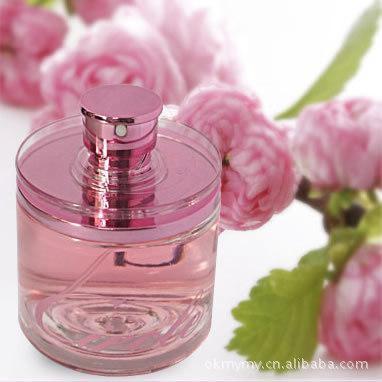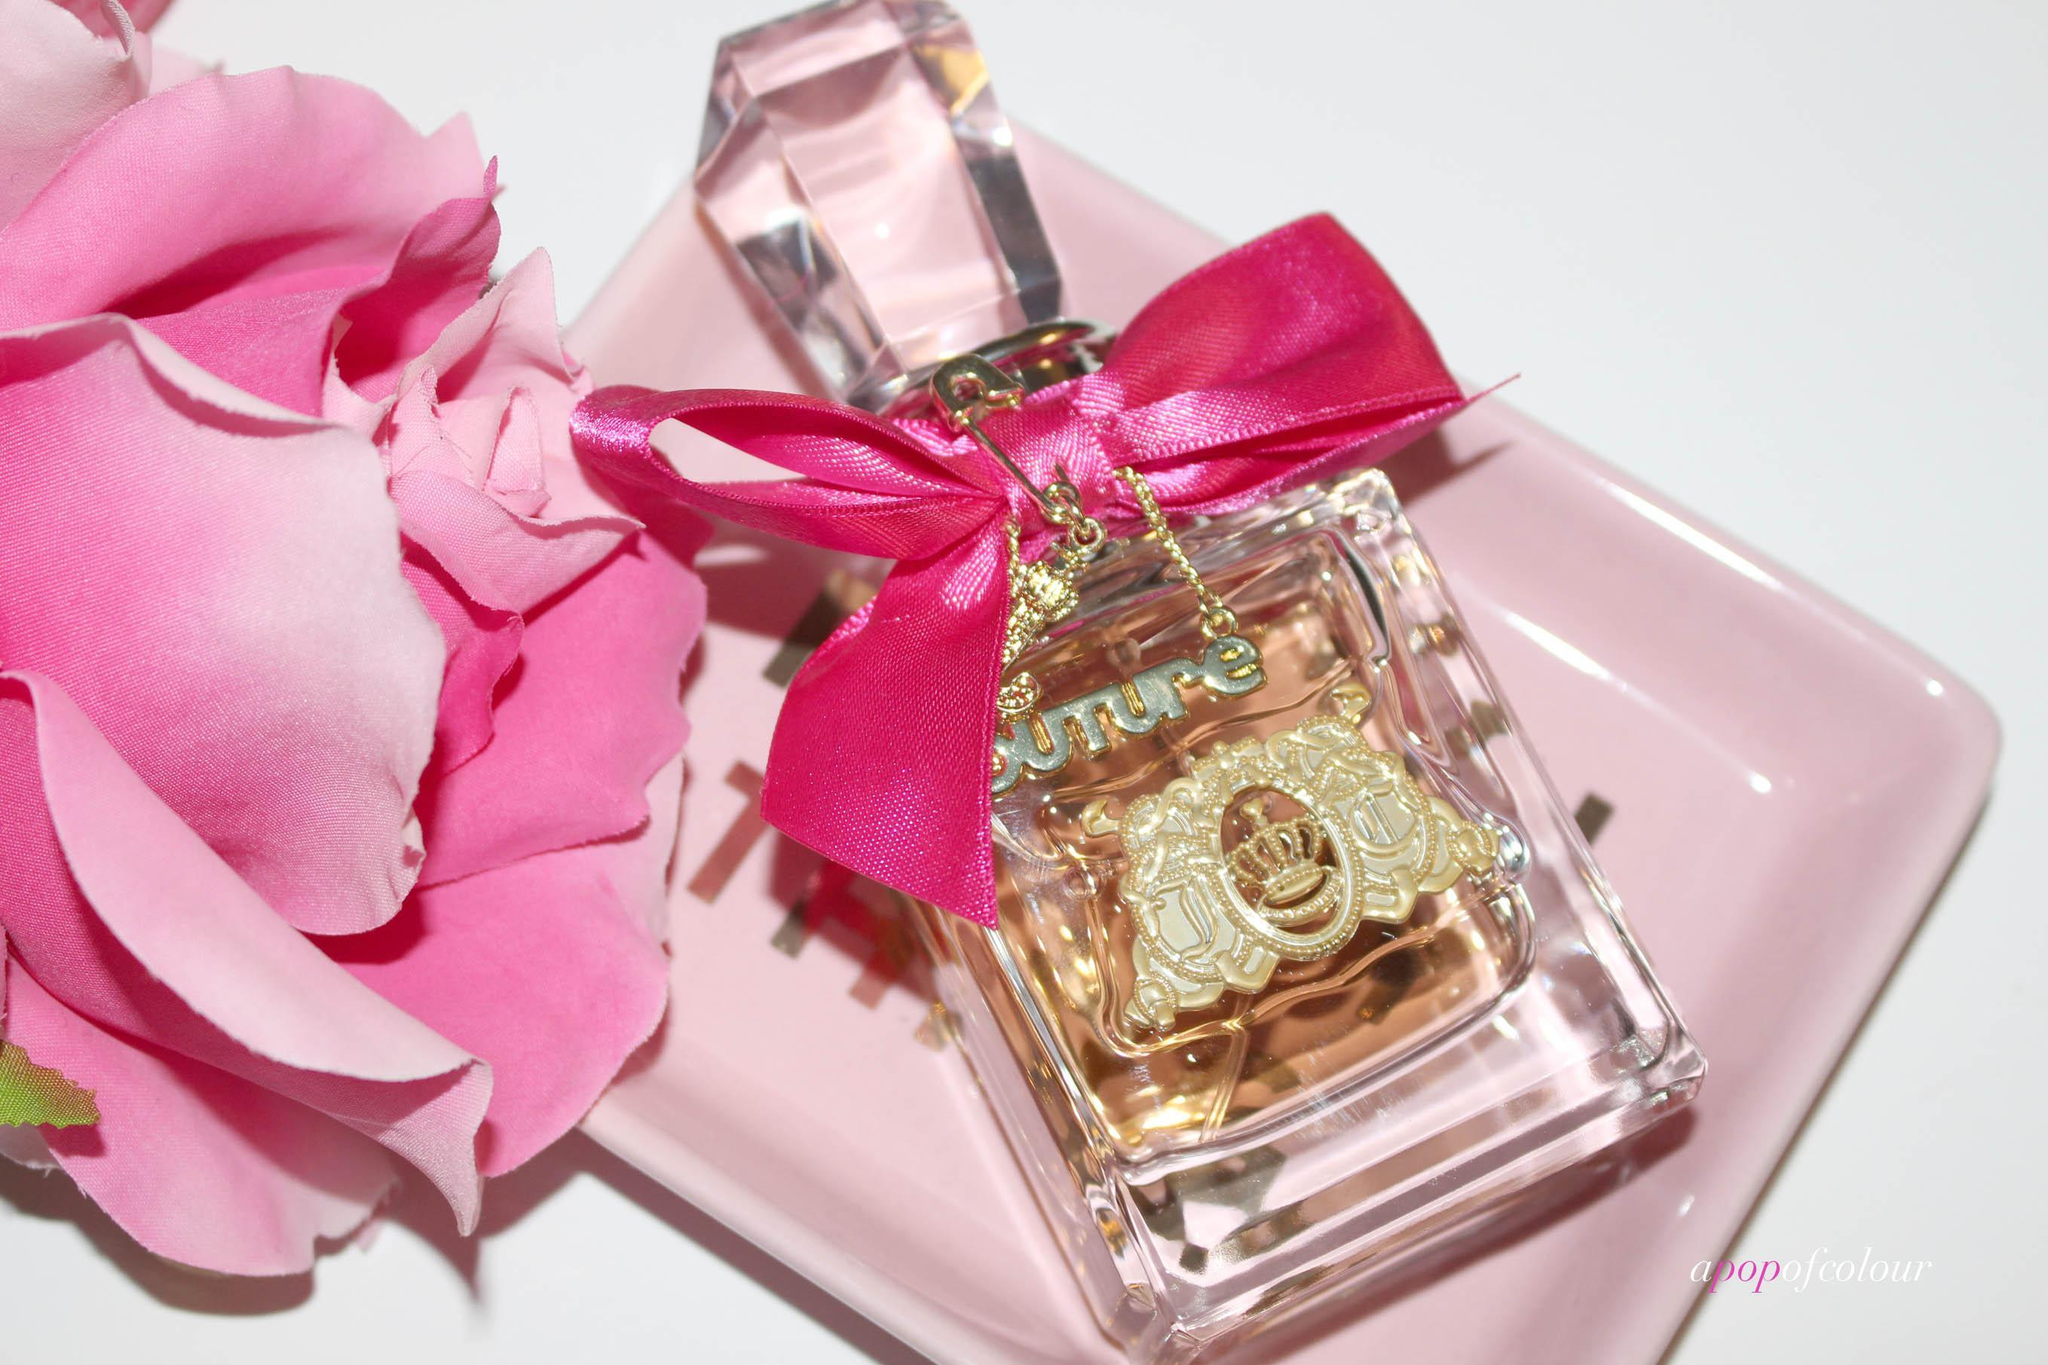The first image is the image on the left, the second image is the image on the right. For the images displayed, is the sentence "The left image features a cylindrical bottle with a hot pink rounded cap standing to the right of an upright hot pink box and slightly overlapping it." factually correct? Answer yes or no. No. 